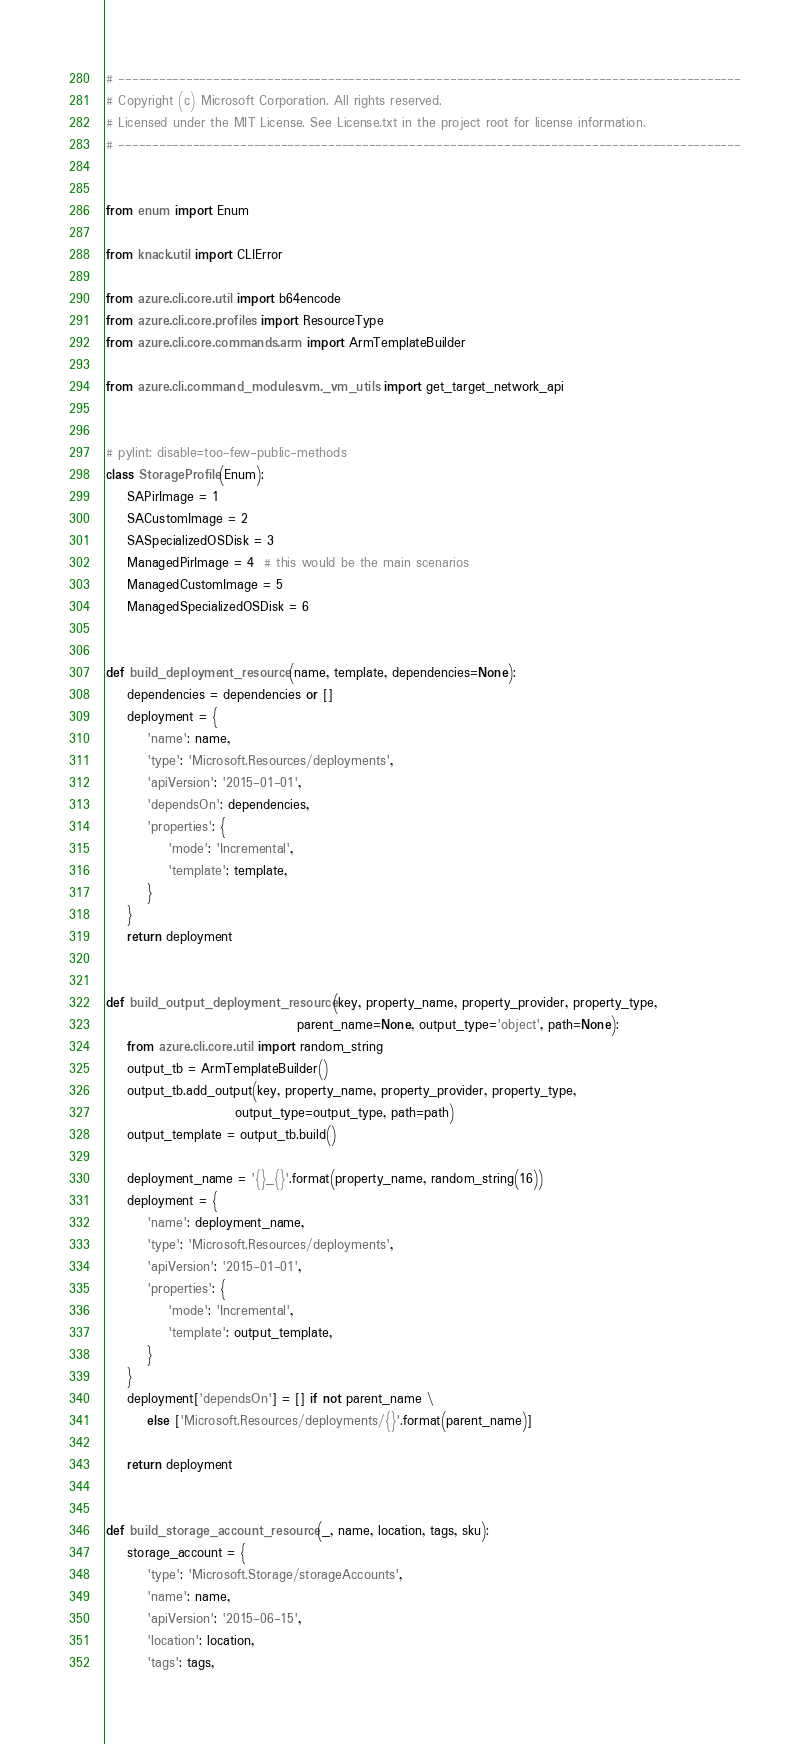<code> <loc_0><loc_0><loc_500><loc_500><_Python_># --------------------------------------------------------------------------------------------
# Copyright (c) Microsoft Corporation. All rights reserved.
# Licensed under the MIT License. See License.txt in the project root for license information.
# --------------------------------------------------------------------------------------------


from enum import Enum

from knack.util import CLIError

from azure.cli.core.util import b64encode
from azure.cli.core.profiles import ResourceType
from azure.cli.core.commands.arm import ArmTemplateBuilder

from azure.cli.command_modules.vm._vm_utils import get_target_network_api


# pylint: disable=too-few-public-methods
class StorageProfile(Enum):
    SAPirImage = 1
    SACustomImage = 2
    SASpecializedOSDisk = 3
    ManagedPirImage = 4  # this would be the main scenarios
    ManagedCustomImage = 5
    ManagedSpecializedOSDisk = 6


def build_deployment_resource(name, template, dependencies=None):
    dependencies = dependencies or []
    deployment = {
        'name': name,
        'type': 'Microsoft.Resources/deployments',
        'apiVersion': '2015-01-01',
        'dependsOn': dependencies,
        'properties': {
            'mode': 'Incremental',
            'template': template,
        }
    }
    return deployment


def build_output_deployment_resource(key, property_name, property_provider, property_type,
                                     parent_name=None, output_type='object', path=None):
    from azure.cli.core.util import random_string
    output_tb = ArmTemplateBuilder()
    output_tb.add_output(key, property_name, property_provider, property_type,
                         output_type=output_type, path=path)
    output_template = output_tb.build()

    deployment_name = '{}_{}'.format(property_name, random_string(16))
    deployment = {
        'name': deployment_name,
        'type': 'Microsoft.Resources/deployments',
        'apiVersion': '2015-01-01',
        'properties': {
            'mode': 'Incremental',
            'template': output_template,
        }
    }
    deployment['dependsOn'] = [] if not parent_name \
        else ['Microsoft.Resources/deployments/{}'.format(parent_name)]

    return deployment


def build_storage_account_resource(_, name, location, tags, sku):
    storage_account = {
        'type': 'Microsoft.Storage/storageAccounts',
        'name': name,
        'apiVersion': '2015-06-15',
        'location': location,
        'tags': tags,</code> 